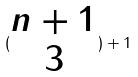<formula> <loc_0><loc_0><loc_500><loc_500>( \begin{matrix} n + 1 \\ 3 \end{matrix} ) + 1</formula> 